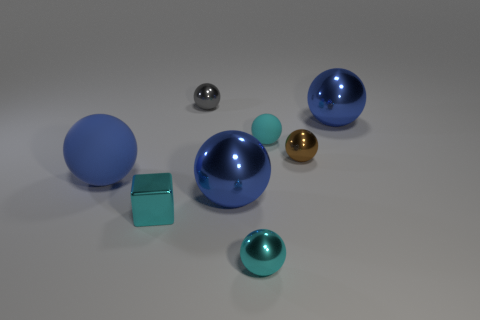Is the shape of the brown object the same as the blue shiny object on the right side of the brown shiny thing?
Provide a succinct answer. Yes. There is another cyan ball that is the same size as the cyan shiny ball; what is it made of?
Your answer should be very brief. Rubber. What number of objects are brown metallic balls or small metal things in front of the cube?
Offer a terse response. 2. What shape is the big blue metallic object that is in front of the matte sphere to the right of the tiny gray shiny object?
Offer a very short reply. Sphere. There is a object that is both right of the blue rubber thing and left of the tiny gray sphere; what size is it?
Ensure brevity in your answer.  Small. Are there any other large blue objects of the same shape as the big matte object?
Keep it short and to the point. Yes. There is a blue ball that is on the left side of the cyan thing that is on the left side of the blue metallic sphere on the left side of the small brown ball; what is it made of?
Your answer should be very brief. Rubber. Is there a metal block that has the same size as the cyan rubber thing?
Your response must be concise. Yes. The big thing that is on the left side of the small cyan thing that is to the left of the gray sphere is what color?
Give a very brief answer. Blue. How many red rubber cylinders are there?
Provide a short and direct response. 0. 